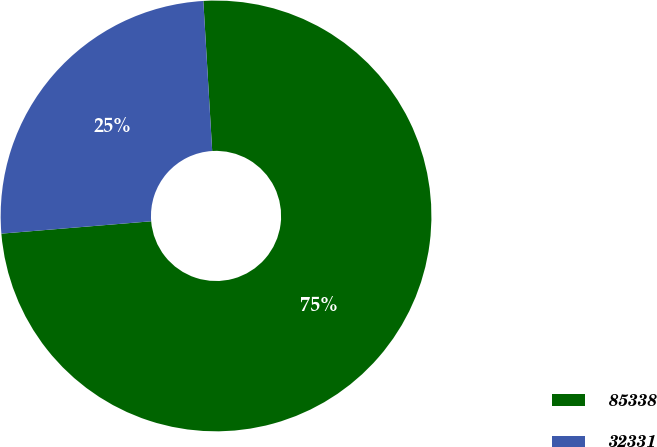Convert chart to OTSL. <chart><loc_0><loc_0><loc_500><loc_500><pie_chart><fcel>85338<fcel>32331<nl><fcel>74.63%<fcel>25.37%<nl></chart> 